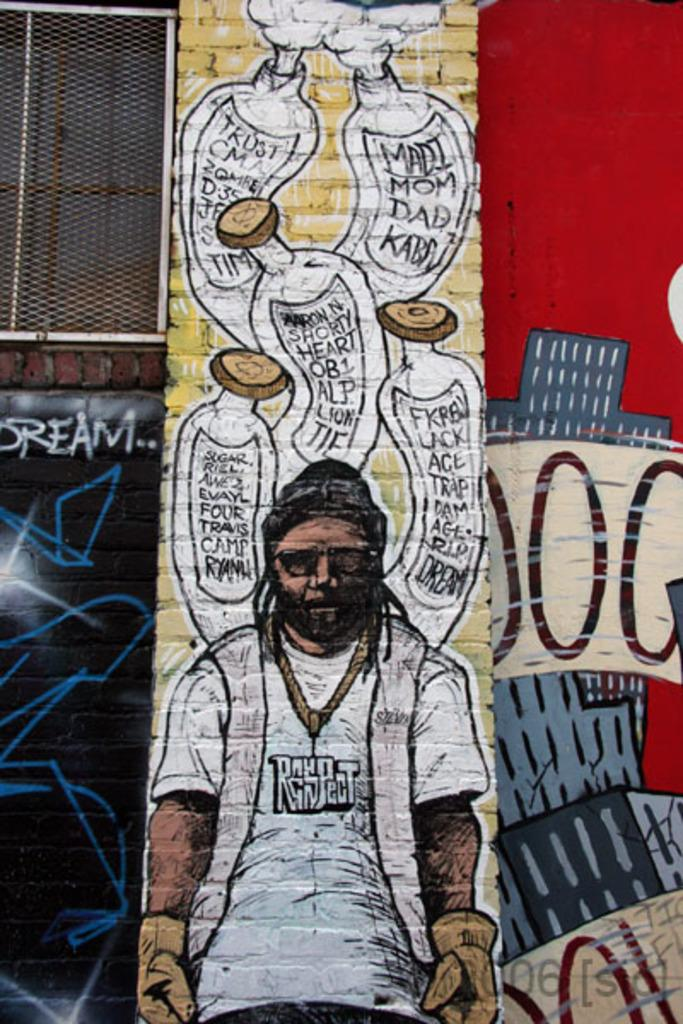What can be seen on the wall in the image? There are paintings on the wall in the image. Where is the window located in the image? The window is on the left side top of the image. How many rings are visible on the linen inen in the image? There is no linen or rings present in the image. What type of frogs can be seen in the window in the image? There are no frogs visible in the window or anywhere else in the image. 